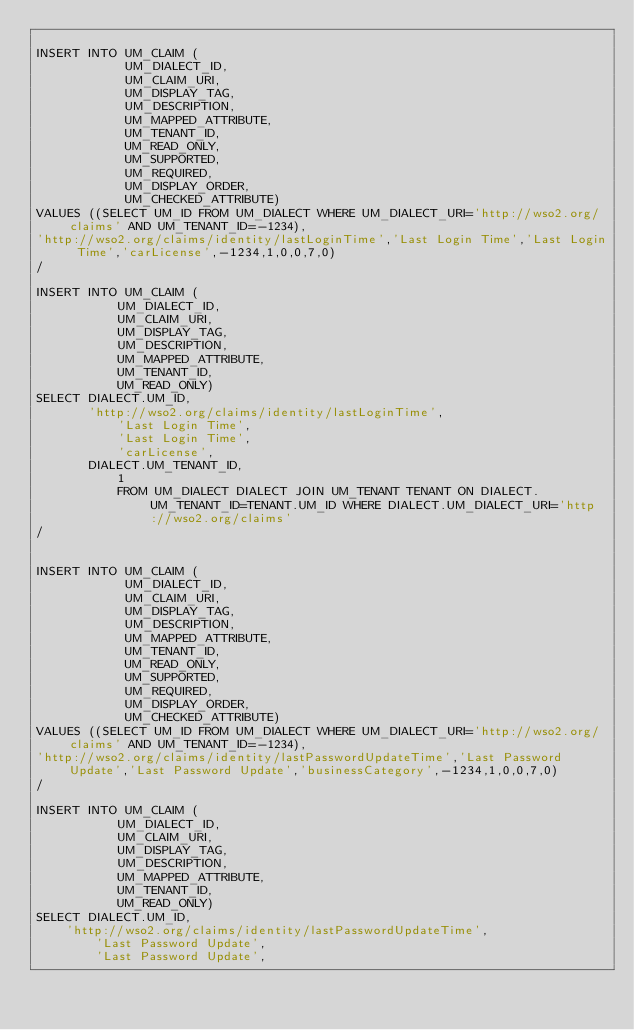<code> <loc_0><loc_0><loc_500><loc_500><_SQL_>
INSERT INTO UM_CLAIM (
            UM_DIALECT_ID,
            UM_CLAIM_URI,
            UM_DISPLAY_TAG,
            UM_DESCRIPTION,
            UM_MAPPED_ATTRIBUTE,
            UM_TENANT_ID,
            UM_READ_ONLY,
            UM_SUPPORTED,
            UM_REQUIRED,
            UM_DISPLAY_ORDER,
            UM_CHECKED_ATTRIBUTE)
VALUES ((SELECT UM_ID FROM UM_DIALECT WHERE UM_DIALECT_URI='http://wso2.org/claims' AND UM_TENANT_ID=-1234),
'http://wso2.org/claims/identity/lastLoginTime','Last Login Time','Last Login Time','carLicense',-1234,1,0,0,7,0)
/

INSERT INTO UM_CLAIM (
           UM_DIALECT_ID,
           UM_CLAIM_URI,
           UM_DISPLAY_TAG,
           UM_DESCRIPTION,
           UM_MAPPED_ATTRIBUTE,
           UM_TENANT_ID,
           UM_READ_ONLY)
SELECT DIALECT.UM_ID,
	   'http://wso2.org/claims/identity/lastLoginTime',
           'Last Login Time',
           'Last Login Time',
           'carLicense',
	   DIALECT.UM_TENANT_ID,
           1
           FROM UM_DIALECT DIALECT JOIN UM_TENANT TENANT ON DIALECT.UM_TENANT_ID=TENANT.UM_ID WHERE DIALECT.UM_DIALECT_URI='http://wso2.org/claims'
/


INSERT INTO UM_CLAIM (
            UM_DIALECT_ID,
            UM_CLAIM_URI,
            UM_DISPLAY_TAG,
            UM_DESCRIPTION,
            UM_MAPPED_ATTRIBUTE,
            UM_TENANT_ID,
            UM_READ_ONLY,
            UM_SUPPORTED,
            UM_REQUIRED,
            UM_DISPLAY_ORDER,
            UM_CHECKED_ATTRIBUTE)
VALUES ((SELECT UM_ID FROM UM_DIALECT WHERE UM_DIALECT_URI='http://wso2.org/claims' AND UM_TENANT_ID=-1234),
'http://wso2.org/claims/identity/lastPasswordUpdateTime','Last Password Update','Last Password Update','businessCategory',-1234,1,0,0,7,0)
/

INSERT INTO UM_CLAIM (
           UM_DIALECT_ID,
           UM_CLAIM_URI,
           UM_DISPLAY_TAG,
           UM_DESCRIPTION,
           UM_MAPPED_ATTRIBUTE,
           UM_TENANT_ID,
           UM_READ_ONLY)
SELECT DIALECT.UM_ID,
	'http://wso2.org/claims/identity/lastPasswordUpdateTime',
        'Last Password Update',
        'Last Password Update',</code> 